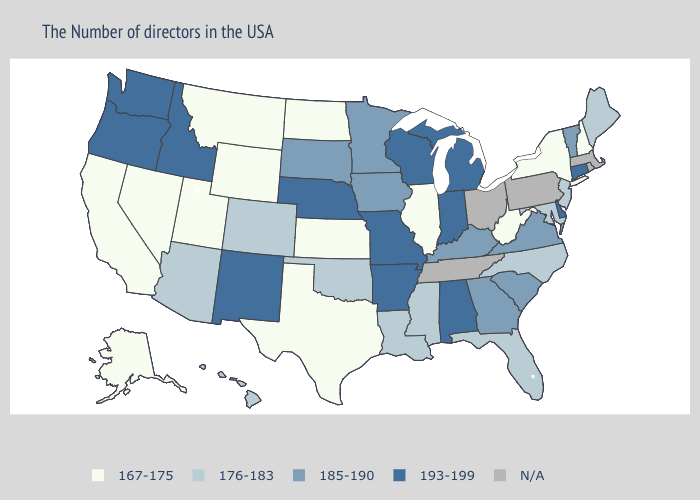Does Delaware have the lowest value in the South?
Write a very short answer. No. Among the states that border Missouri , which have the highest value?
Give a very brief answer. Arkansas, Nebraska. What is the value of Hawaii?
Write a very short answer. 176-183. Name the states that have a value in the range 185-190?
Concise answer only. Vermont, Virginia, South Carolina, Georgia, Kentucky, Minnesota, Iowa, South Dakota. Does Oklahoma have the lowest value in the South?
Keep it brief. No. Does the first symbol in the legend represent the smallest category?
Short answer required. Yes. Among the states that border Missouri , which have the lowest value?
Short answer required. Illinois, Kansas. What is the value of Minnesota?
Short answer required. 185-190. What is the lowest value in the USA?
Be succinct. 167-175. Does South Carolina have the lowest value in the USA?
Write a very short answer. No. Name the states that have a value in the range 176-183?
Concise answer only. Maine, New Jersey, Maryland, North Carolina, Florida, Mississippi, Louisiana, Oklahoma, Colorado, Arizona, Hawaii. Does Connecticut have the highest value in the USA?
Be succinct. Yes. Name the states that have a value in the range 167-175?
Quick response, please. New Hampshire, New York, West Virginia, Illinois, Kansas, Texas, North Dakota, Wyoming, Utah, Montana, Nevada, California, Alaska. 